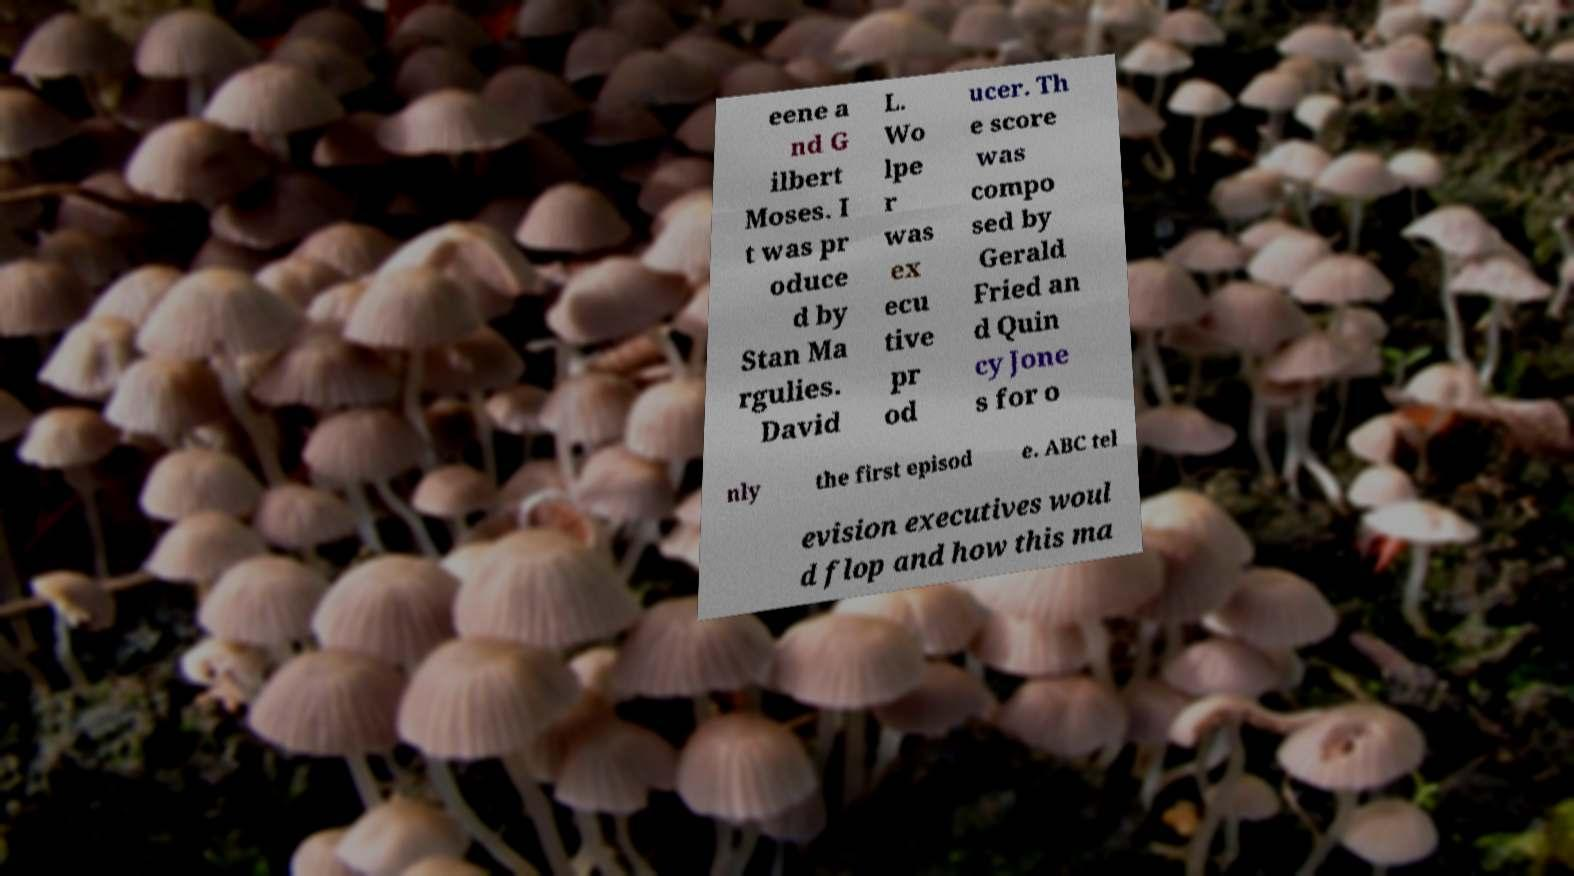Please identify and transcribe the text found in this image. eene a nd G ilbert Moses. I t was pr oduce d by Stan Ma rgulies. David L. Wo lpe r was ex ecu tive pr od ucer. Th e score was compo sed by Gerald Fried an d Quin cy Jone s for o nly the first episod e. ABC tel evision executives woul d flop and how this ma 